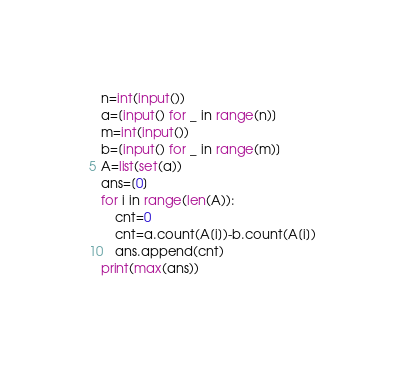<code> <loc_0><loc_0><loc_500><loc_500><_Python_>n=int(input())
a=[input() for _ in range(n)]
m=int(input())
b=[input() for _ in range(m)]
A=list(set(a))
ans=[0]
for i in range(len(A)):
    cnt=0
    cnt=a.count(A[i])-b.count(A[i])
    ans.append(cnt)
print(max(ans))</code> 